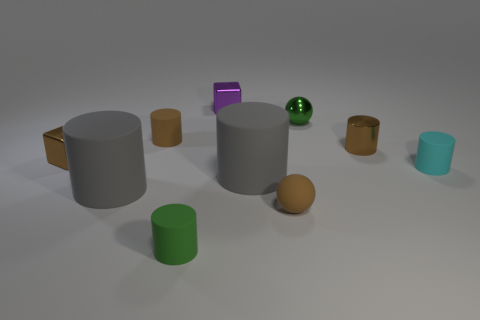Subtract all small brown rubber cylinders. How many cylinders are left? 5 Subtract all gray cylinders. How many cylinders are left? 4 Subtract all yellow cylinders. Subtract all blue blocks. How many cylinders are left? 6 Subtract all spheres. How many objects are left? 8 Subtract all tiny purple metallic things. Subtract all cyan matte cylinders. How many objects are left? 8 Add 8 gray rubber objects. How many gray rubber objects are left? 10 Add 1 purple matte spheres. How many purple matte spheres exist? 1 Subtract 0 purple cylinders. How many objects are left? 10 